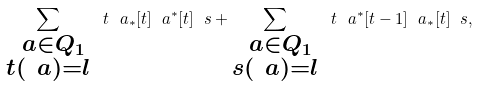<formula> <loc_0><loc_0><loc_500><loc_500>\sum _ { \substack { \ a \in Q _ { 1 } \\ t ( \ a ) = l } } \ t \ a _ { * } [ t ] \ a ^ { * } [ t ] \ s + \sum _ { \substack { \ a \in Q _ { 1 } \\ s ( \ a ) = l } } \ t \ a ^ { * } [ t - 1 ] \ a _ { * } [ t ] \ s ,</formula> 